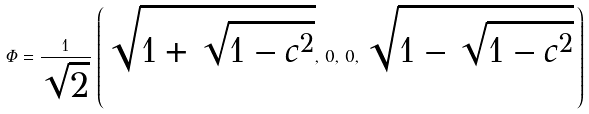<formula> <loc_0><loc_0><loc_500><loc_500>\Phi = \frac { 1 } { \sqrt { 2 } } \, \left ( \, \sqrt { 1 + \sqrt { 1 - c ^ { 2 } } } , \, 0 , \, 0 , \, \sqrt { 1 - \sqrt { 1 - c ^ { 2 } } } \, \right )</formula> 